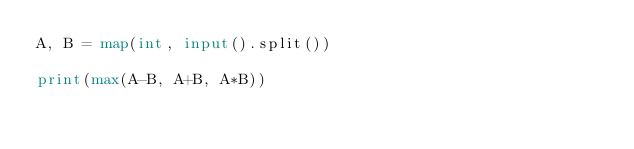<code> <loc_0><loc_0><loc_500><loc_500><_Python_>A, B = map(int, input().split())

print(max(A-B, A+B, A*B))</code> 